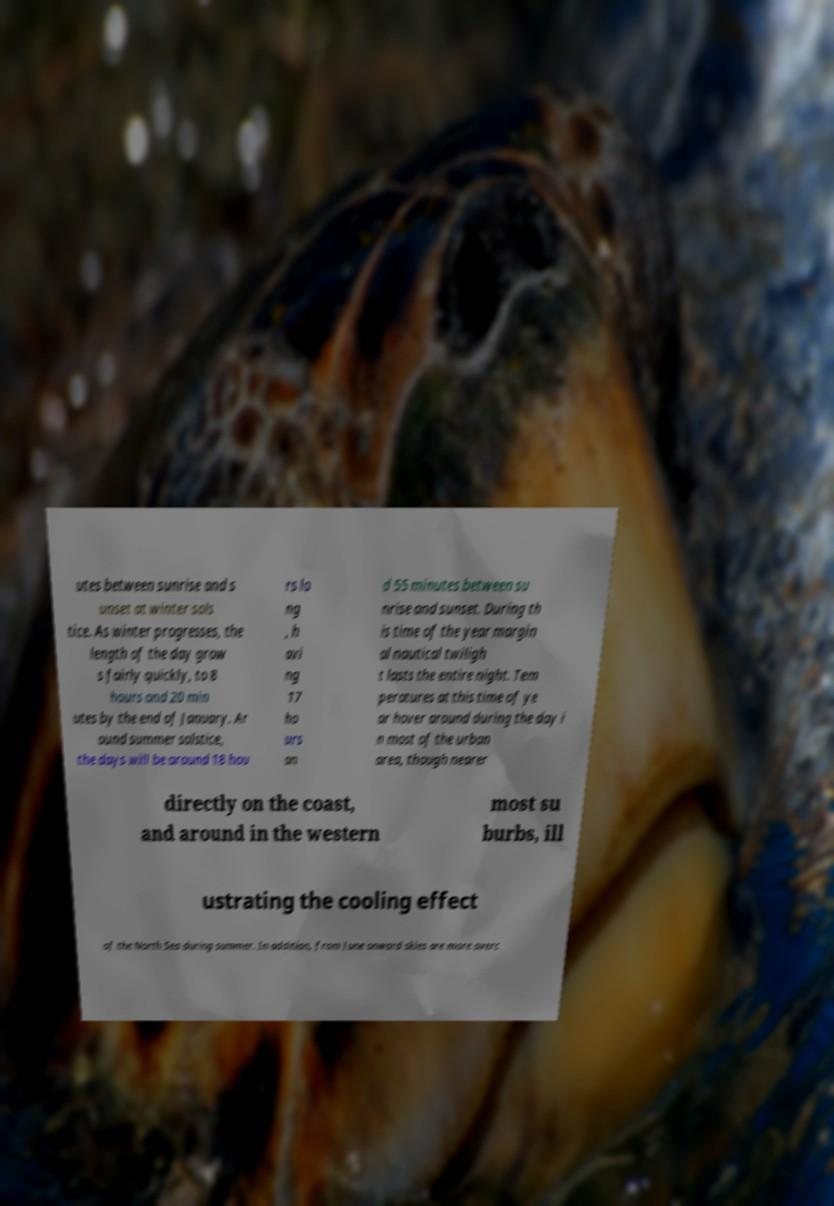I need the written content from this picture converted into text. Can you do that? utes between sunrise and s unset at winter sols tice. As winter progresses, the length of the day grow s fairly quickly, to 8 hours and 20 min utes by the end of January. Ar ound summer solstice, the days will be around 18 hou rs lo ng , h avi ng 17 ho urs an d 55 minutes between su nrise and sunset. During th is time of the year margin al nautical twiligh t lasts the entire night. Tem peratures at this time of ye ar hover around during the day i n most of the urban area, though nearer directly on the coast, and around in the western most su burbs, ill ustrating the cooling effect of the North Sea during summer. In addition, from June onward skies are more overc 